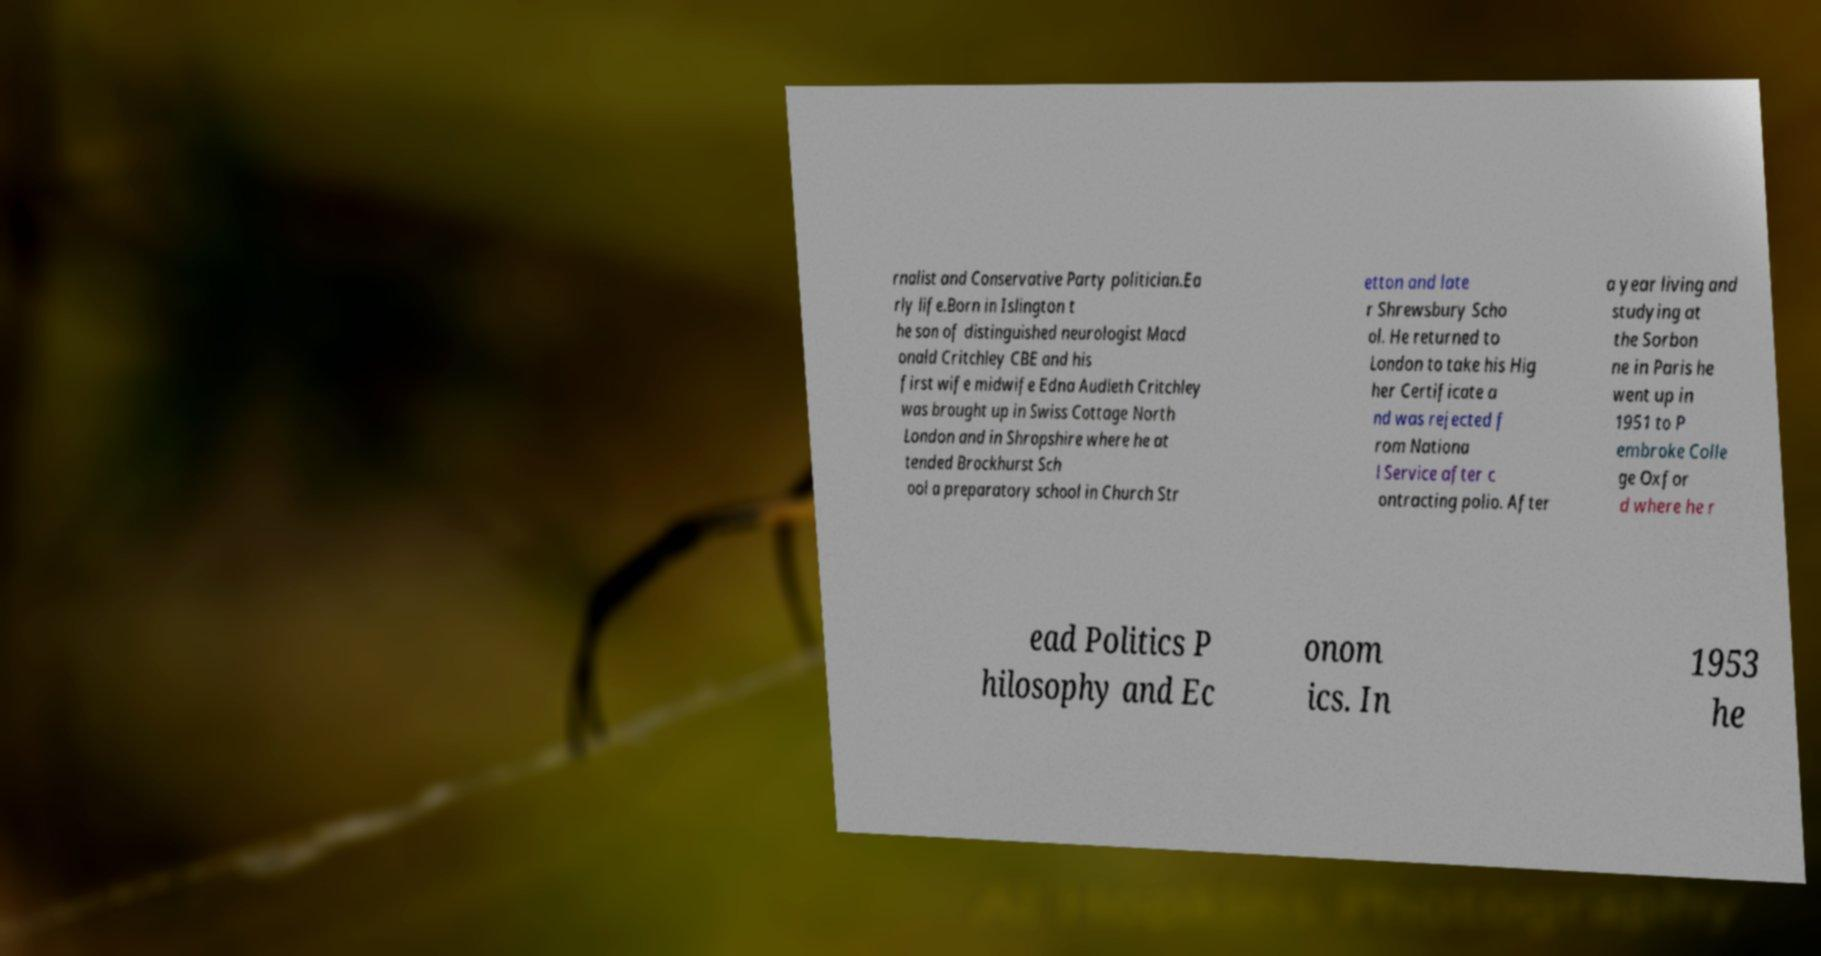Please identify and transcribe the text found in this image. rnalist and Conservative Party politician.Ea rly life.Born in Islington t he son of distinguished neurologist Macd onald Critchley CBE and his first wife midwife Edna Audleth Critchley was brought up in Swiss Cottage North London and in Shropshire where he at tended Brockhurst Sch ool a preparatory school in Church Str etton and late r Shrewsbury Scho ol. He returned to London to take his Hig her Certificate a nd was rejected f rom Nationa l Service after c ontracting polio. After a year living and studying at the Sorbon ne in Paris he went up in 1951 to P embroke Colle ge Oxfor d where he r ead Politics P hilosophy and Ec onom ics. In 1953 he 